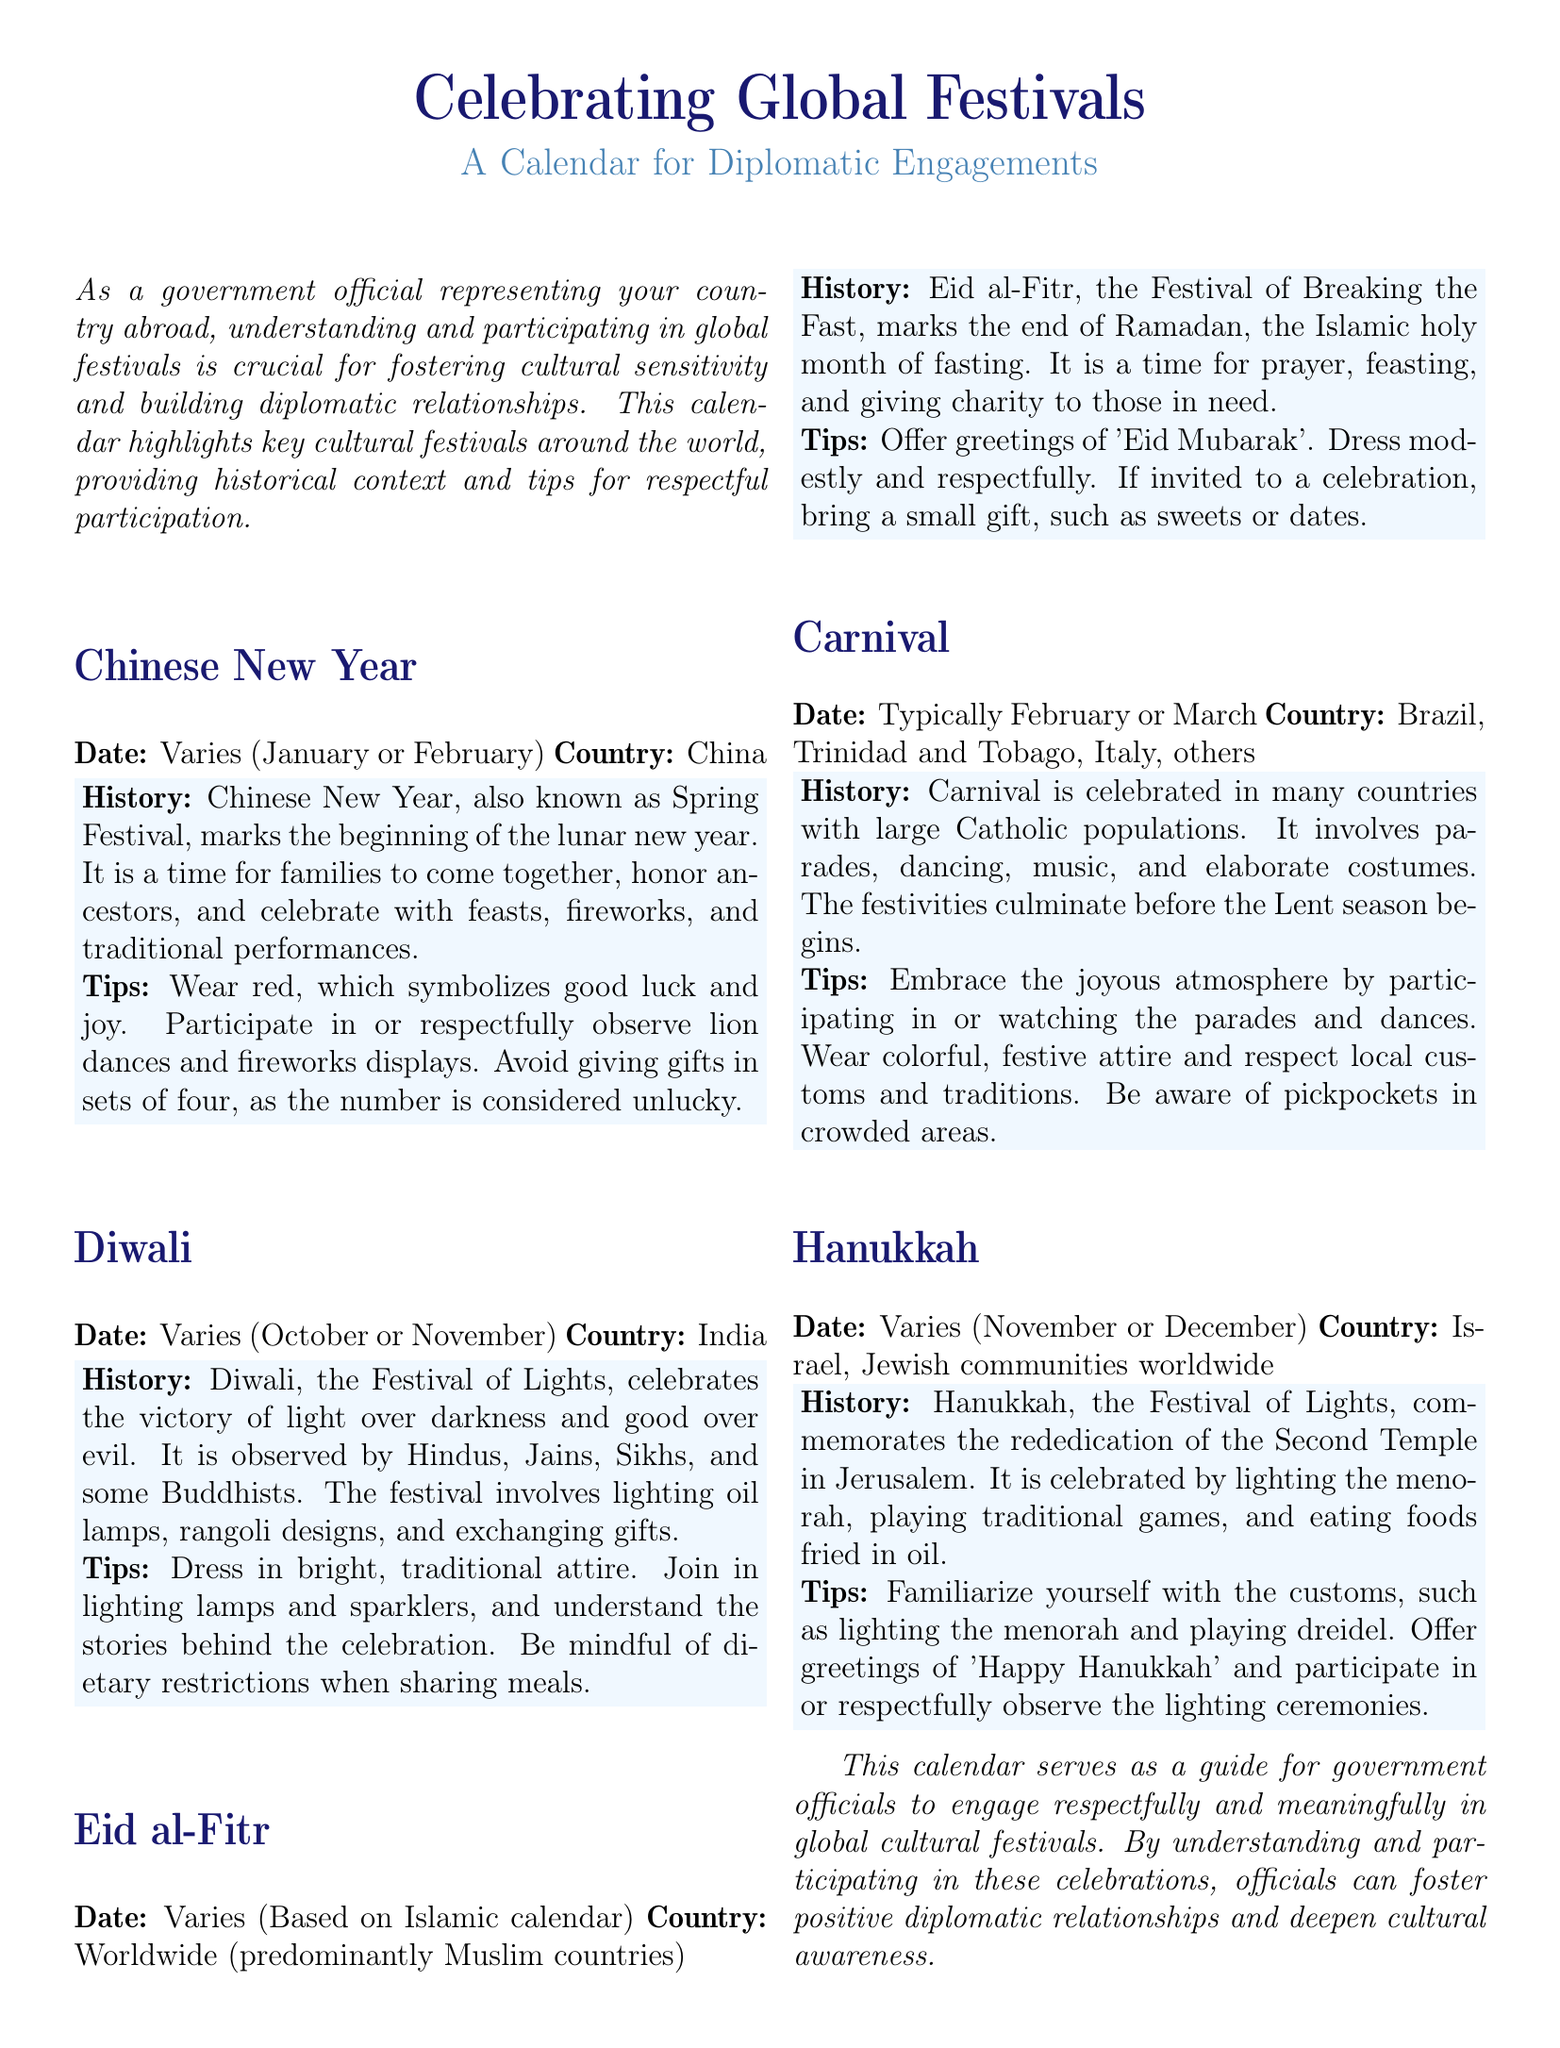what is the date range for Chinese New Year? The date for Chinese New Year varies but is generally in January or February.
Answer: January or February what festival is celebrated as the Festival of Lights? Diwali and Hanukkah are both referred to as the Festival of Lights in the document.
Answer: Diwali, Hanukkah what should you avoid gifting in during Chinese New Year? It is considered unlucky to give gifts in sets of four during Chinese New Year.
Answer: Sets of four what is the historical significance of Eid al-Fitr? Eid al-Fitr marks the end of Ramadan, which is the Islamic holy month of fasting.
Answer: End of Ramadan how should one dress for Diwali? It is recommended to dress in bright, traditional attire during Diwali.
Answer: Bright, traditional attire which countries predominantly celebrate Carnival? Brazil and Trinidad and Tobago are mentioned as countries where Carnival is celebrated.
Answer: Brazil, Trinidad and Tobago what is suggested if invited to an Eid al-Fitr celebration? A small gift such as sweets or dates is suggested to bring if invited to an Eid al-Fitr celebration.
Answer: Sweets or dates what is the purpose of this calendar? The calendar serves as a guide for government officials to engage respectfully in global cultural festivals.
Answer: Engage respectfully in global cultural festivals what festive attire is recommended during Carnival? Colorful, festive attire is recommended for participants during Carnival.
Answer: Colorful, festive attire 